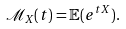Convert formula to latex. <formula><loc_0><loc_0><loc_500><loc_500>\mathcal { M } _ { X } ( t ) = \mathbb { E } ( e ^ { t X } ) .</formula> 